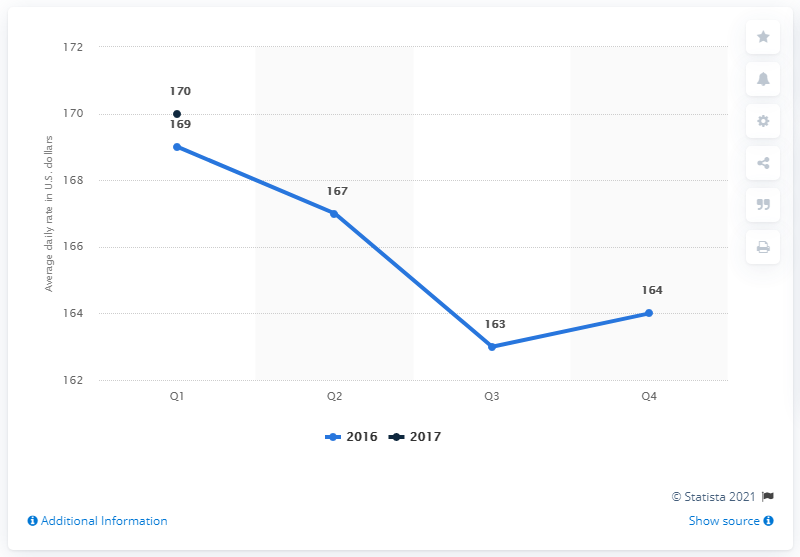List a handful of essential elements in this visual. The average daily rate of hotels in Dallas during the first quarter of 2017 was approximately 170 USD. 